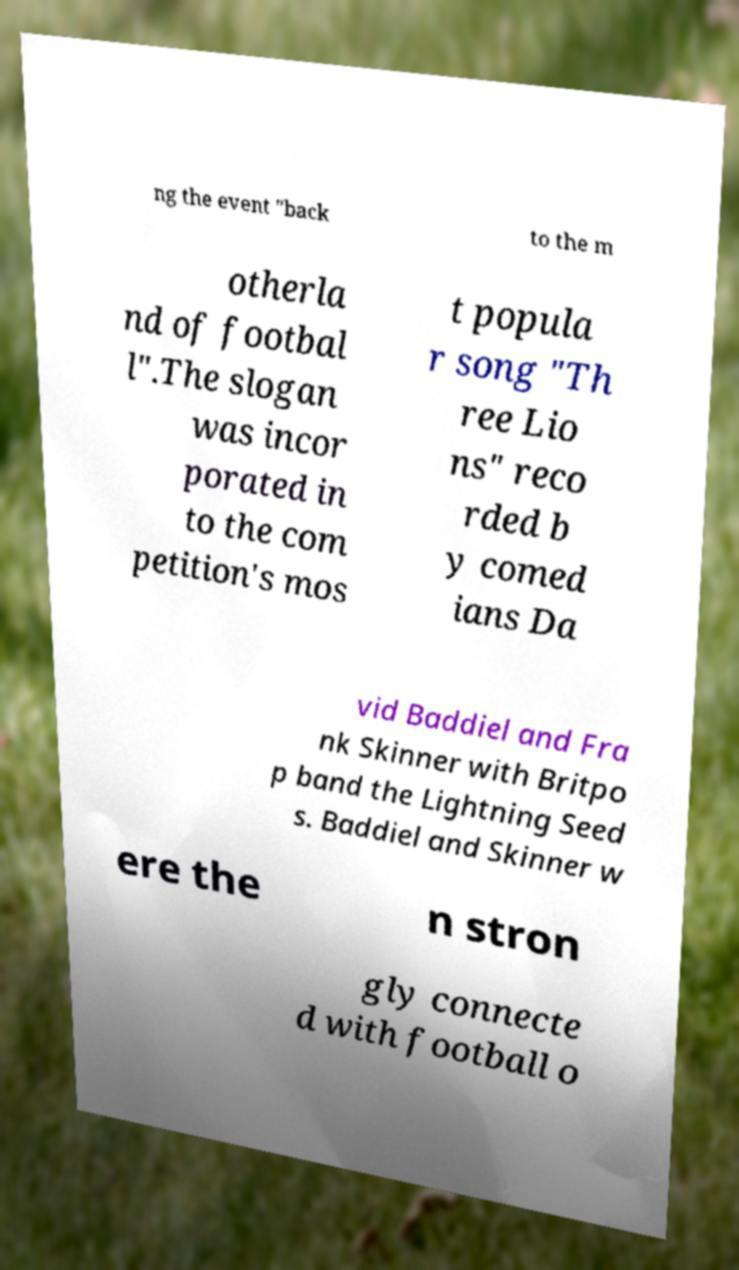Can you accurately transcribe the text from the provided image for me? ng the event "back to the m otherla nd of footbal l".The slogan was incor porated in to the com petition's mos t popula r song "Th ree Lio ns" reco rded b y comed ians Da vid Baddiel and Fra nk Skinner with Britpo p band the Lightning Seed s. Baddiel and Skinner w ere the n stron gly connecte d with football o 